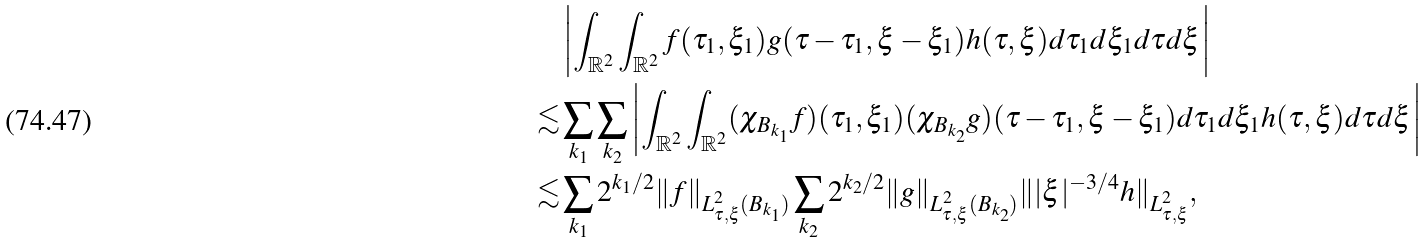Convert formula to latex. <formula><loc_0><loc_0><loc_500><loc_500>& \left | \int _ { \mathbb { R } ^ { 2 } } \int _ { \mathbb { R } ^ { 2 } } f ( \tau _ { 1 } , \xi _ { 1 } ) g ( \tau - \tau _ { 1 } , \xi - \xi _ { 1 } ) h ( \tau , \xi ) d \tau _ { 1 } d \xi _ { 1 } d \tau d \xi \right | \\ \lesssim & \sum _ { k _ { 1 } } \sum _ { k _ { 2 } } \left | \int _ { \mathbb { R } ^ { 2 } } \int _ { \mathbb { R } ^ { 2 } } ( \chi _ { B _ { k _ { 1 } } } f ) ( \tau _ { 1 } , \xi _ { 1 } ) ( \chi _ { B _ { k _ { 2 } } } g ) ( \tau - \tau _ { 1 } , \xi - \xi _ { 1 } ) d \tau _ { 1 } d \xi _ { 1 } h ( \tau , \xi ) d \tau d \xi \right | \\ \lesssim & \sum _ { k _ { 1 } } 2 ^ { k _ { 1 } / 2 } \| f \| _ { L _ { \tau , \xi } ^ { 2 } ( B _ { k _ { 1 } } ) } \sum _ { k _ { 2 } } 2 ^ { k _ { 2 } / 2 } \| g \| _ { L _ { \tau , \xi } ^ { 2 } ( B _ { k _ { 2 } } ) } \| | \xi | ^ { - 3 / 4 } h \| _ { L _ { \tau , \xi } ^ { 2 } } ,</formula> 